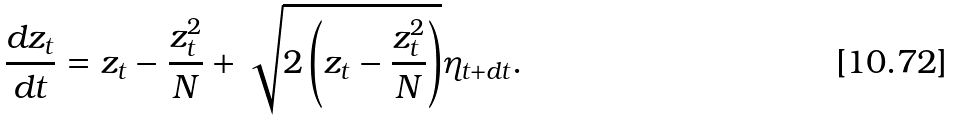Convert formula to latex. <formula><loc_0><loc_0><loc_500><loc_500>\frac { d z _ { t } } { d t } = z _ { t } - \frac { z _ { t } ^ { 2 } } { N } + \sqrt { 2 \left ( z _ { t } - \frac { z _ { t } ^ { 2 } } { N } \right ) } \eta _ { t + d t } .</formula> 